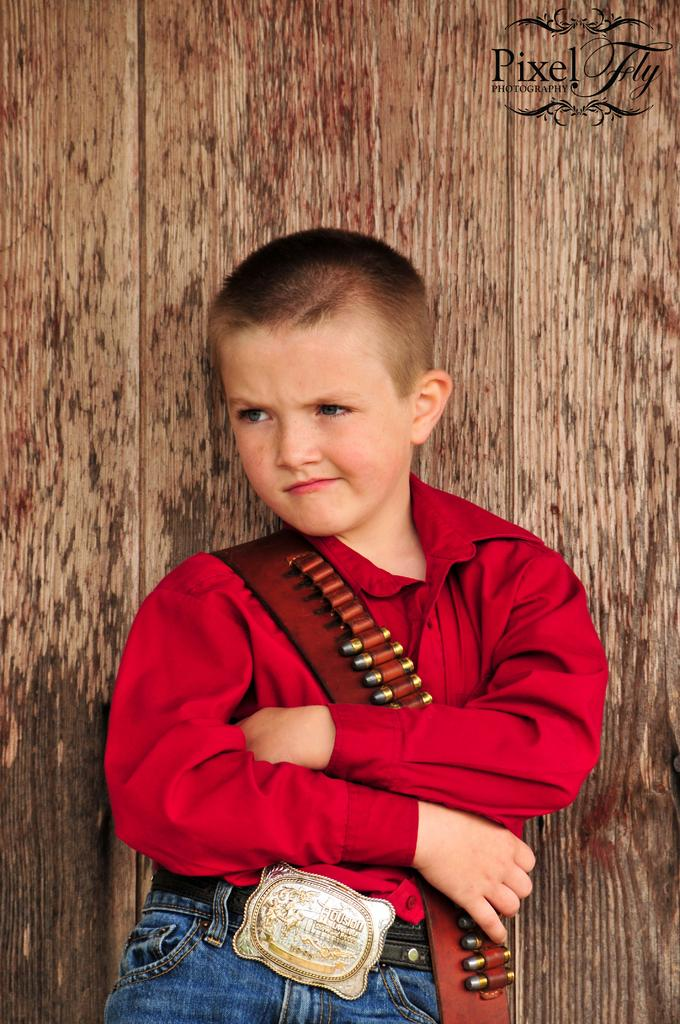What is the main subject of the image? The main subject of the image is a boy. Where is the boy positioned in the image? The boy is standing in the center of the image. What can be seen in the background of the image? There is a wall in the background of the image. What type of faucet is visible in the image? There is no faucet present in the image. How many dolls can be seen interacting with the boy in the image? There are no dolls present in the image. 